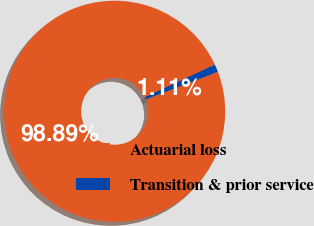Convert chart. <chart><loc_0><loc_0><loc_500><loc_500><pie_chart><fcel>Actuarial loss<fcel>Transition & prior service<nl><fcel>98.89%<fcel>1.11%<nl></chart> 